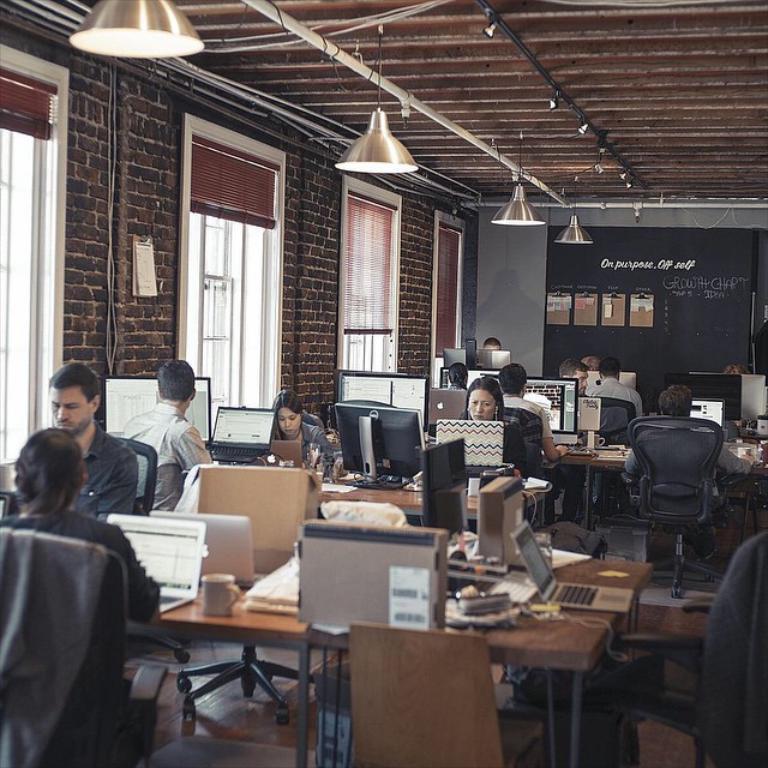Could you give a brief overview of what you see in this image? The photo is taken inside a office room. There are many chairs and tables. Many people are sitting on chairs. On the table there are laptop,mug paper and few other things. On the left top there are many windows. On the back there is wall. There are some notice board on the wall. On the top some lights are there hanged from the roof. 